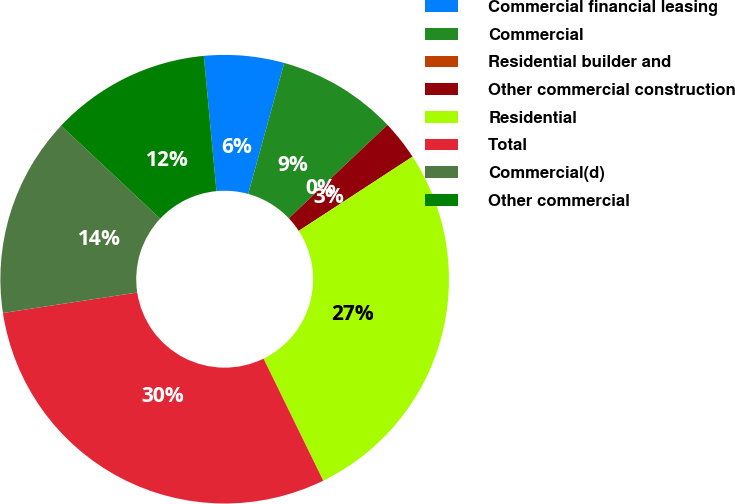Convert chart to OTSL. <chart><loc_0><loc_0><loc_500><loc_500><pie_chart><fcel>Commercial financial leasing<fcel>Commercial<fcel>Residential builder and<fcel>Other commercial construction<fcel>Residential<fcel>Total<fcel>Commercial(d)<fcel>Other commercial<nl><fcel>5.76%<fcel>8.64%<fcel>0.0%<fcel>2.88%<fcel>26.95%<fcel>29.83%<fcel>14.4%<fcel>11.52%<nl></chart> 